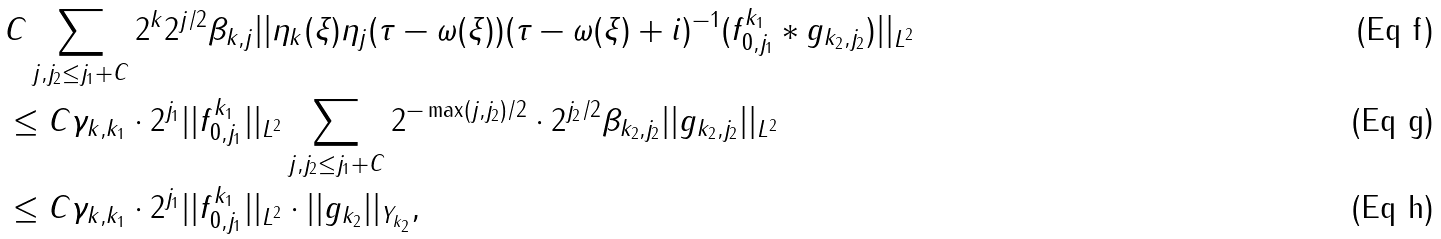Convert formula to latex. <formula><loc_0><loc_0><loc_500><loc_500>& C \sum _ { j , j _ { 2 } \leq j _ { 1 } + C } 2 ^ { k } 2 ^ { j / 2 } \beta _ { k , j } | | \eta _ { k } ( \xi ) \eta _ { j } ( \tau - \omega ( \xi ) ) ( \tau - \omega ( \xi ) + i ) ^ { - 1 } ( f _ { 0 , j _ { 1 } } ^ { k _ { 1 } } \ast g _ { k _ { 2 } , j _ { 2 } } ) | | _ { L ^ { 2 } } \\ & \leq C \gamma _ { k , k _ { 1 } } \cdot 2 ^ { j _ { 1 } } | | f ^ { k _ { 1 } } _ { 0 , j _ { 1 } } | | _ { L ^ { 2 } } \sum _ { j , j _ { 2 } \leq j _ { 1 } + C } 2 ^ { - \max ( j , j _ { 2 } ) / 2 } \cdot 2 ^ { j _ { 2 } / 2 } \beta _ { k _ { 2 } , j _ { 2 } } | | g _ { k _ { 2 } , j _ { 2 } } | | _ { L ^ { 2 } } \\ & \leq C \gamma _ { k , k _ { 1 } } \cdot 2 ^ { j _ { 1 } } | | f _ { 0 , j _ { 1 } } ^ { k _ { 1 } } | | _ { L ^ { 2 } } \cdot | | g _ { k _ { 2 } } | | _ { Y _ { k _ { 2 } } } ,</formula> 